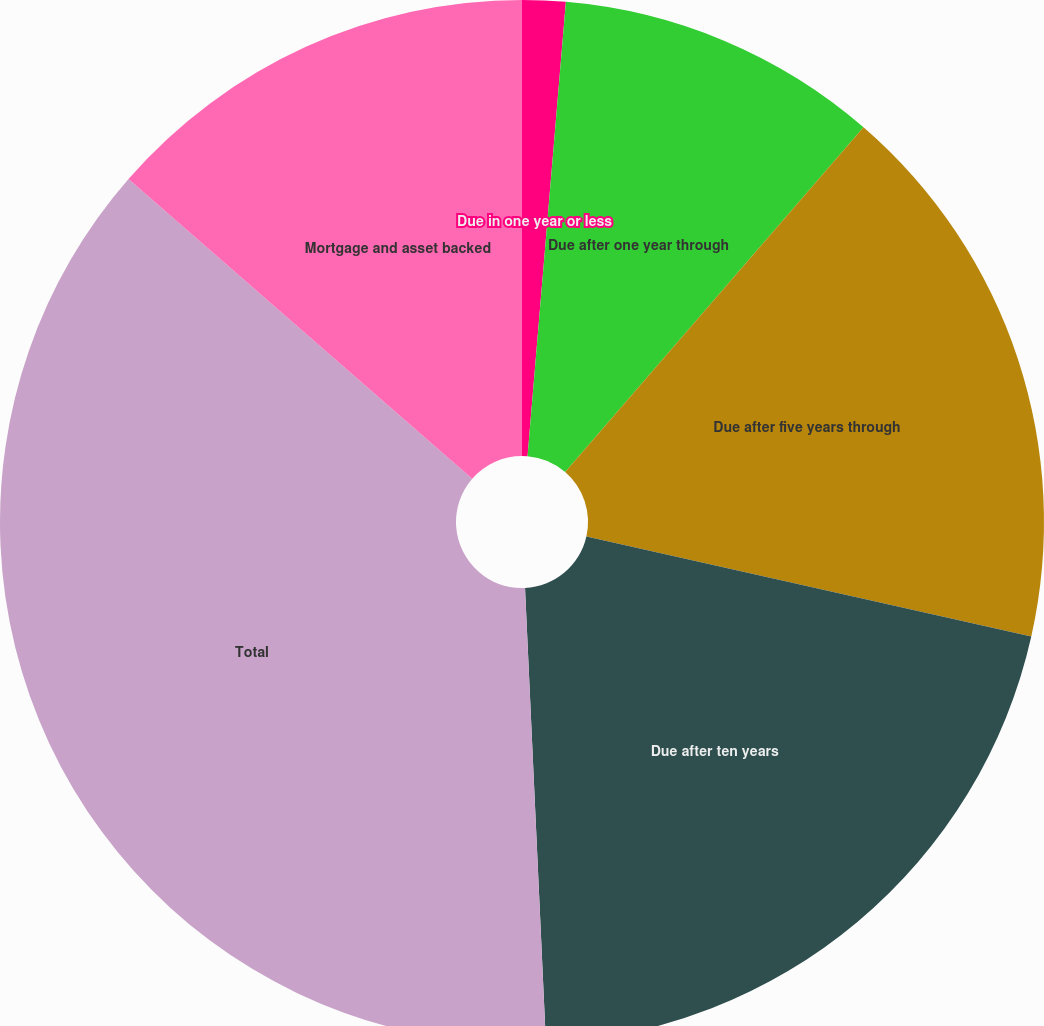<chart> <loc_0><loc_0><loc_500><loc_500><pie_chart><fcel>Due in one year or less<fcel>Due after one year through<fcel>Due after five years through<fcel>Due after ten years<fcel>Total<fcel>Mortgage and asset backed<nl><fcel>1.34%<fcel>10.01%<fcel>17.17%<fcel>20.75%<fcel>37.14%<fcel>13.59%<nl></chart> 